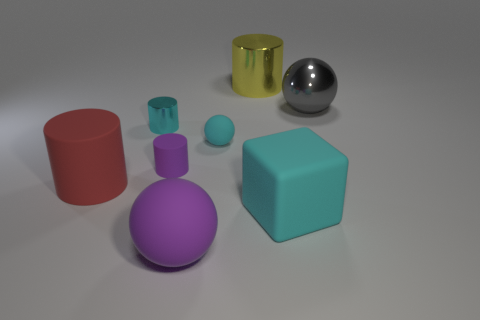Add 1 large shiny blocks. How many objects exist? 9 Subtract all cubes. How many objects are left? 7 Subtract 0 brown cylinders. How many objects are left? 8 Subtract all tiny red shiny spheres. Subtract all tiny purple matte cylinders. How many objects are left? 7 Add 4 cyan balls. How many cyan balls are left? 5 Add 6 tiny shiny things. How many tiny shiny things exist? 7 